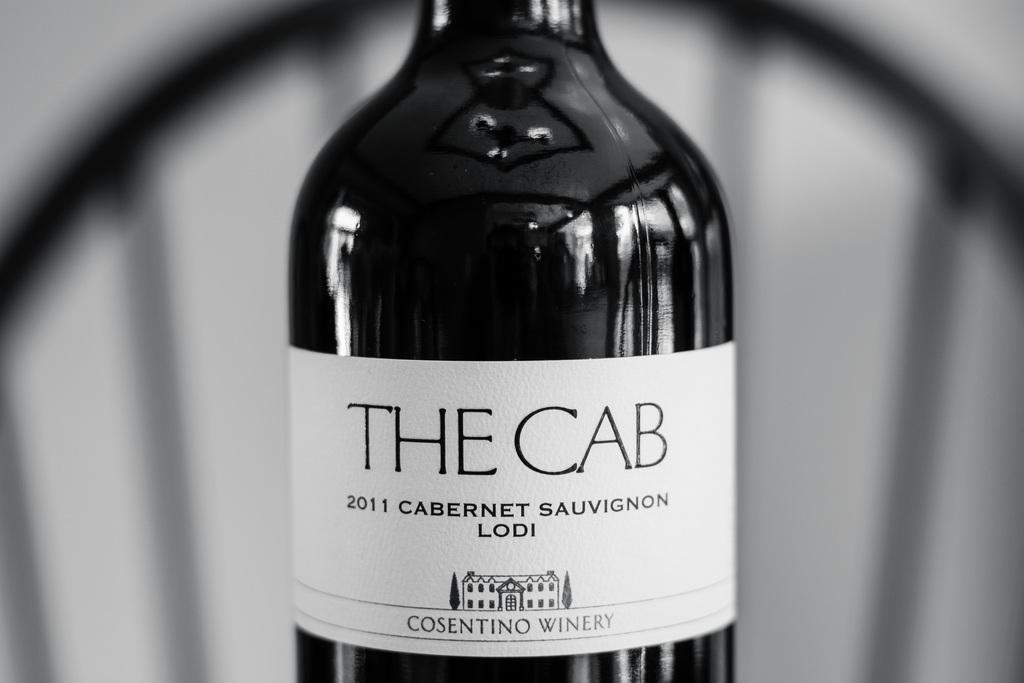Provide a one-sentence caption for the provided image. A bottle of 2011 cabernet sauvignon from the Consentino Winery. 